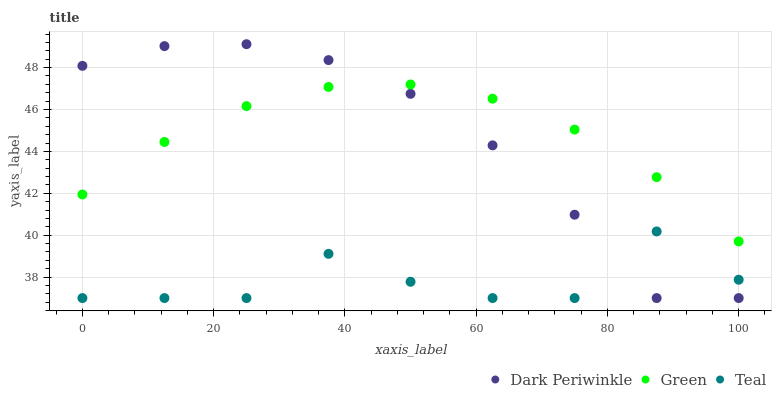Does Teal have the minimum area under the curve?
Answer yes or no. Yes. Does Green have the maximum area under the curve?
Answer yes or no. Yes. Does Dark Periwinkle have the minimum area under the curve?
Answer yes or no. No. Does Dark Periwinkle have the maximum area under the curve?
Answer yes or no. No. Is Green the smoothest?
Answer yes or no. Yes. Is Teal the roughest?
Answer yes or no. Yes. Is Dark Periwinkle the smoothest?
Answer yes or no. No. Is Dark Periwinkle the roughest?
Answer yes or no. No. Does Dark Periwinkle have the lowest value?
Answer yes or no. Yes. Does Dark Periwinkle have the highest value?
Answer yes or no. Yes. Does Teal have the highest value?
Answer yes or no. No. Is Teal less than Green?
Answer yes or no. Yes. Is Green greater than Teal?
Answer yes or no. Yes. Does Green intersect Dark Periwinkle?
Answer yes or no. Yes. Is Green less than Dark Periwinkle?
Answer yes or no. No. Is Green greater than Dark Periwinkle?
Answer yes or no. No. Does Teal intersect Green?
Answer yes or no. No. 